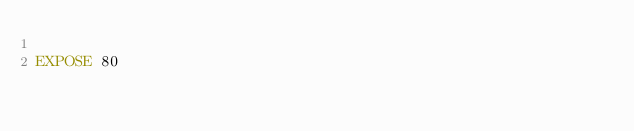Convert code to text. <code><loc_0><loc_0><loc_500><loc_500><_Dockerfile_>
EXPOSE 80
</code> 